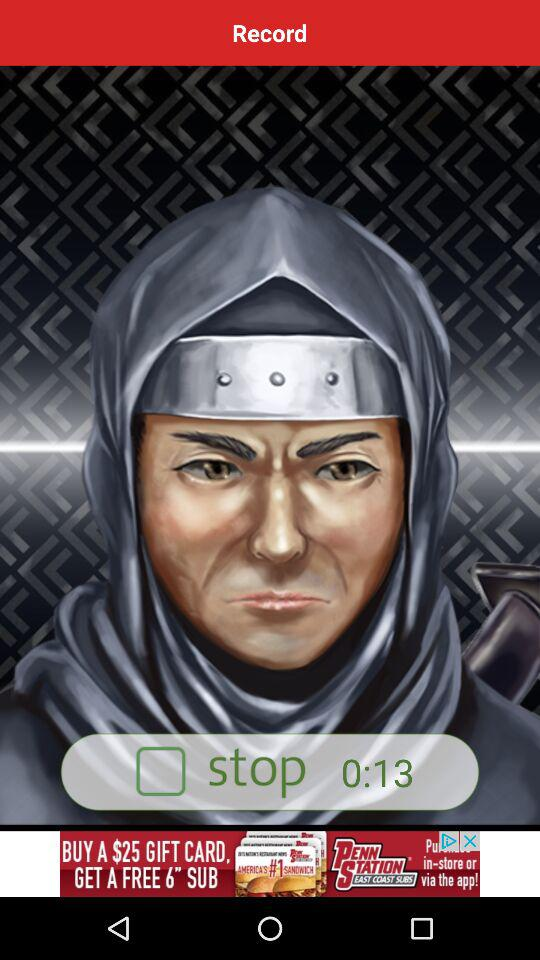How long has the recording been recorded? The recording has been recorded for 13 seconds. 